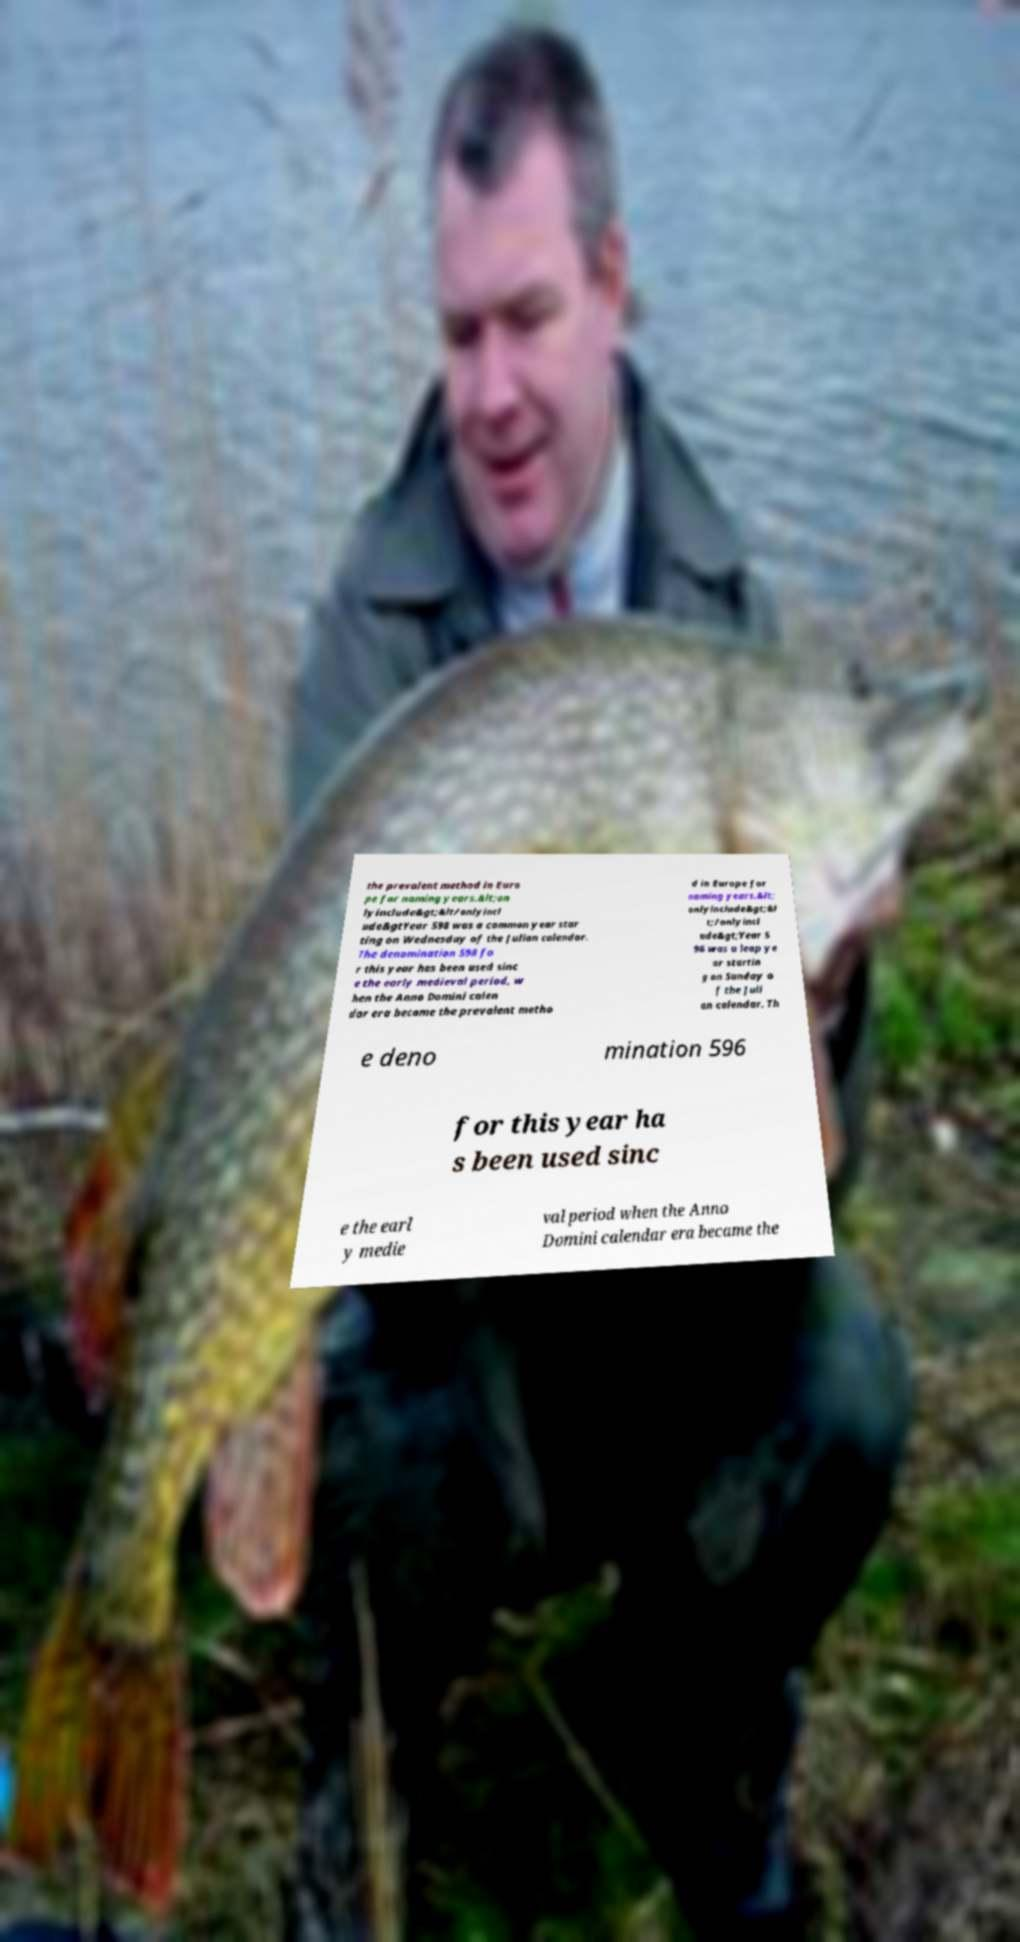Can you read and provide the text displayed in the image?This photo seems to have some interesting text. Can you extract and type it out for me? the prevalent method in Euro pe for naming years.&lt;on lyinclude&gt;&lt/onlyincl ude&gtYear 598 was a common year star ting on Wednesday of the Julian calendar. The denomination 598 fo r this year has been used sinc e the early medieval period, w hen the Anno Domini calen dar era became the prevalent metho d in Europe for naming years.&lt; onlyinclude&gt;&l t;/onlyincl ude&gt;Year 5 96 was a leap ye ar startin g on Sunday o f the Juli an calendar. Th e deno mination 596 for this year ha s been used sinc e the earl y medie val period when the Anno Domini calendar era became the 